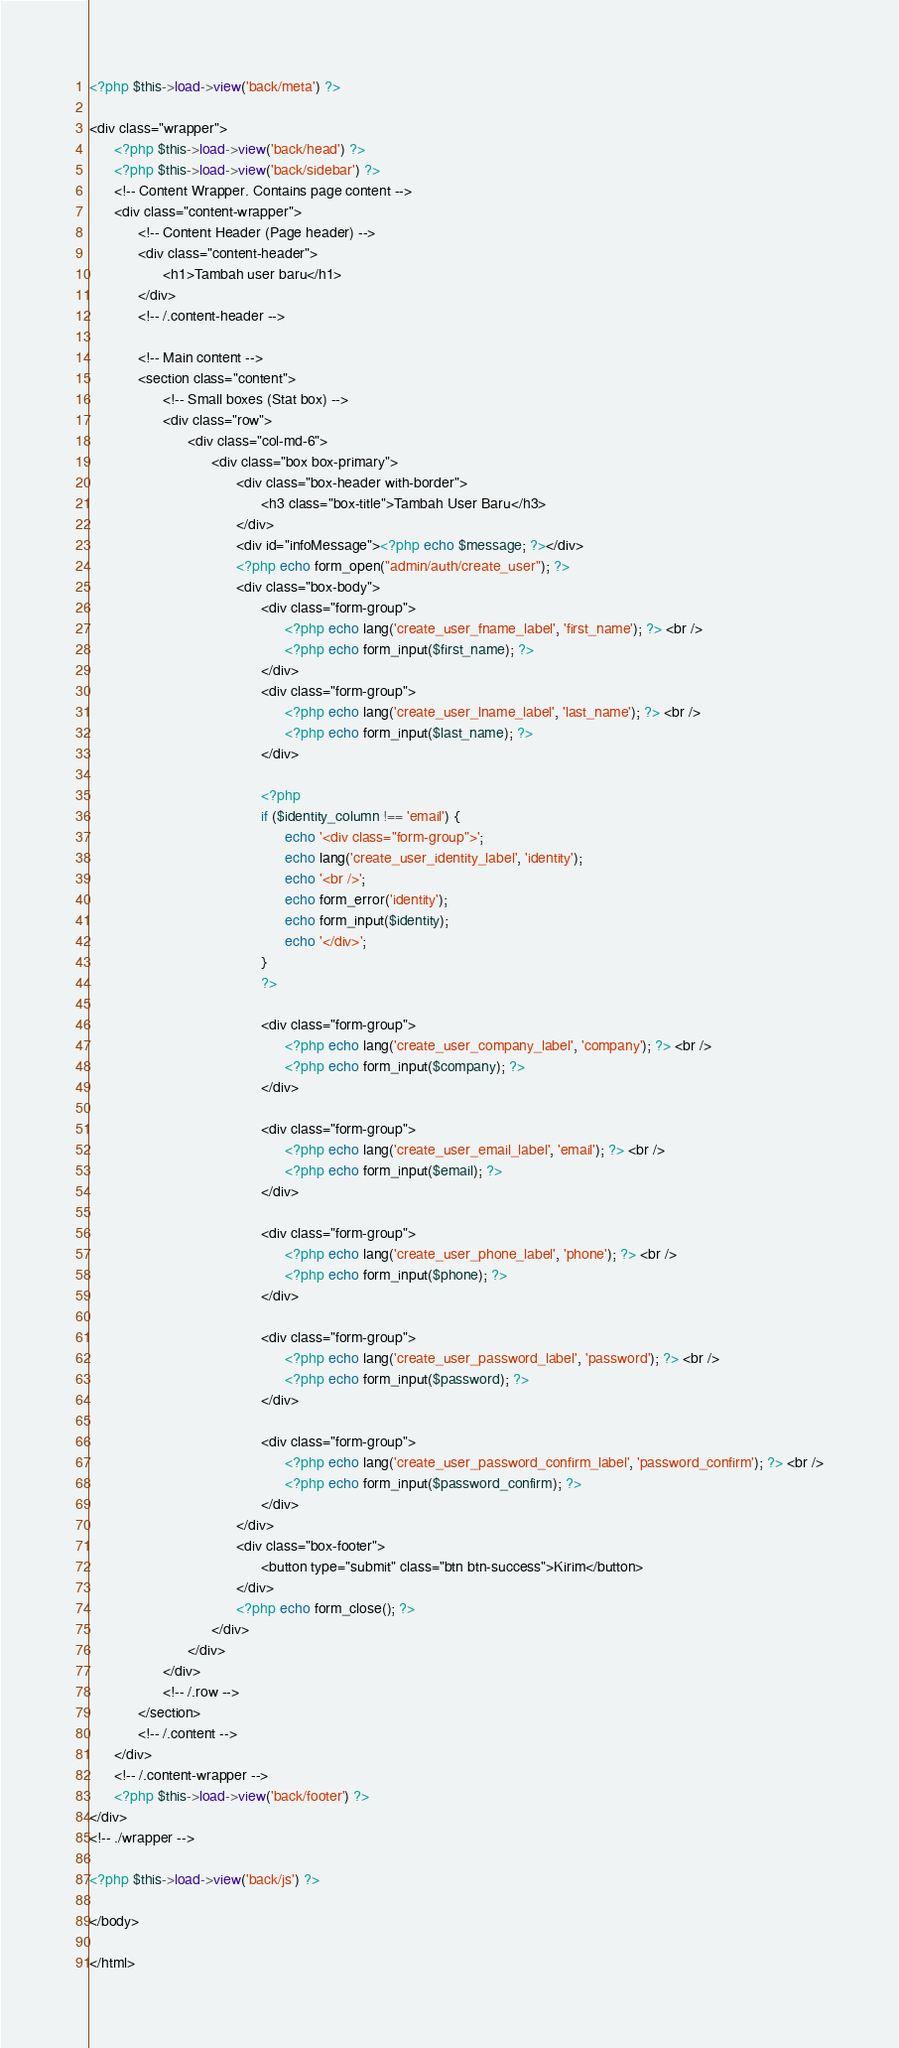<code> <loc_0><loc_0><loc_500><loc_500><_PHP_><?php $this->load->view('back/meta') ?>

<div class="wrapper">
      <?php $this->load->view('back/head') ?>
      <?php $this->load->view('back/sidebar') ?>
      <!-- Content Wrapper. Contains page content -->
      <div class="content-wrapper">
            <!-- Content Header (Page header) -->
            <div class="content-header">
                  <h1>Tambah user baru</h1>
            </div>
            <!-- /.content-header -->

            <!-- Main content -->
            <section class="content">
                  <!-- Small boxes (Stat box) -->
                  <div class="row">
                        <div class="col-md-6">
                              <div class="box box-primary">
                                    <div class="box-header with-border">
                                          <h3 class="box-title">Tambah User Baru</h3>
                                    </div>
                                    <div id="infoMessage"><?php echo $message; ?></div>
                                    <?php echo form_open("admin/auth/create_user"); ?>
                                    <div class="box-body">
                                          <div class="form-group">
                                                <?php echo lang('create_user_fname_label', 'first_name'); ?> <br />
                                                <?php echo form_input($first_name); ?>
                                          </div>
                                          <div class="form-group">
                                                <?php echo lang('create_user_lname_label', 'last_name'); ?> <br />
                                                <?php echo form_input($last_name); ?>
                                          </div>

                                          <?php
                                          if ($identity_column !== 'email') {
                                                echo '<div class="form-group">';
                                                echo lang('create_user_identity_label', 'identity');
                                                echo '<br />';
                                                echo form_error('identity');
                                                echo form_input($identity);
                                                echo '</div>';
                                          }
                                          ?>

                                          <div class="form-group">
                                                <?php echo lang('create_user_company_label', 'company'); ?> <br />
                                                <?php echo form_input($company); ?>
                                          </div>

                                          <div class="form-group">
                                                <?php echo lang('create_user_email_label', 'email'); ?> <br />
                                                <?php echo form_input($email); ?>
                                          </div>

                                          <div class="form-group">
                                                <?php echo lang('create_user_phone_label', 'phone'); ?> <br />
                                                <?php echo form_input($phone); ?>
                                          </div>

                                          <div class="form-group">
                                                <?php echo lang('create_user_password_label', 'password'); ?> <br />
                                                <?php echo form_input($password); ?>
                                          </div>

                                          <div class="form-group">
                                                <?php echo lang('create_user_password_confirm_label', 'password_confirm'); ?> <br />
                                                <?php echo form_input($password_confirm); ?>
                                          </div>
                                    </div>
                                    <div class="box-footer">
                                          <button type="submit" class="btn btn-success">Kirim</button>
                                    </div>
                                    <?php echo form_close(); ?>
                              </div>
                        </div>
                  </div>
                  <!-- /.row -->
            </section>
            <!-- /.content -->
      </div>
      <!-- /.content-wrapper -->
      <?php $this->load->view('back/footer') ?>
</div>
<!-- ./wrapper -->

<?php $this->load->view('back/js') ?>

</body>

</html></code> 